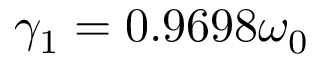Convert formula to latex. <formula><loc_0><loc_0><loc_500><loc_500>\gamma _ { 1 } = 0 . 9 6 9 8 \omega _ { 0 }</formula> 